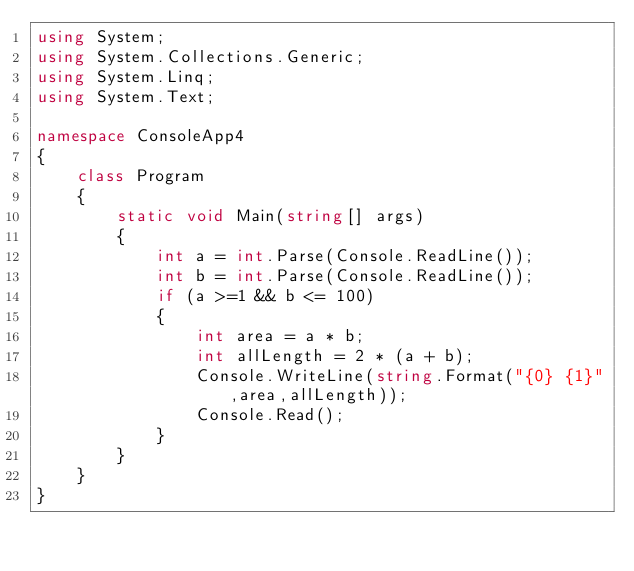<code> <loc_0><loc_0><loc_500><loc_500><_C#_>using System;
using System.Collections.Generic;
using System.Linq;
using System.Text;

namespace ConsoleApp4
{
    class Program
    {
        static void Main(string[] args)
        {
            int a = int.Parse(Console.ReadLine());
            int b = int.Parse(Console.ReadLine());
            if (a >=1 && b <= 100)
            {
                int area = a * b;
                int allLength = 2 * (a + b);
                Console.WriteLine(string.Format("{0} {1}",area,allLength));
                Console.Read();
            }
        }
    }
}

</code> 